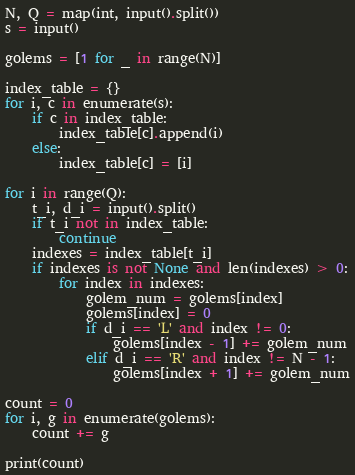<code> <loc_0><loc_0><loc_500><loc_500><_Python_>N, Q = map(int, input().split())
s = input()

golems = [1 for _ in range(N)]

index_table = {}
for i, c in enumerate(s):
    if c in index_table:
        index_table[c].append(i)
    else:
        index_table[c] = [i]

for i in range(Q):
    t_i, d_i = input().split()
    if t_i not in index_table:
        continue
    indexes = index_table[t_i]
    if indexes is not None and len(indexes) > 0:
        for index in indexes:
            golem_num = golems[index]
            golems[index] = 0
            if d_i == 'L' and index != 0:
                golems[index - 1] += golem_num
            elif d_i == 'R' and index != N - 1:
                golems[index + 1] += golem_num

count = 0
for i, g in enumerate(golems):
    count += g

print(count)</code> 